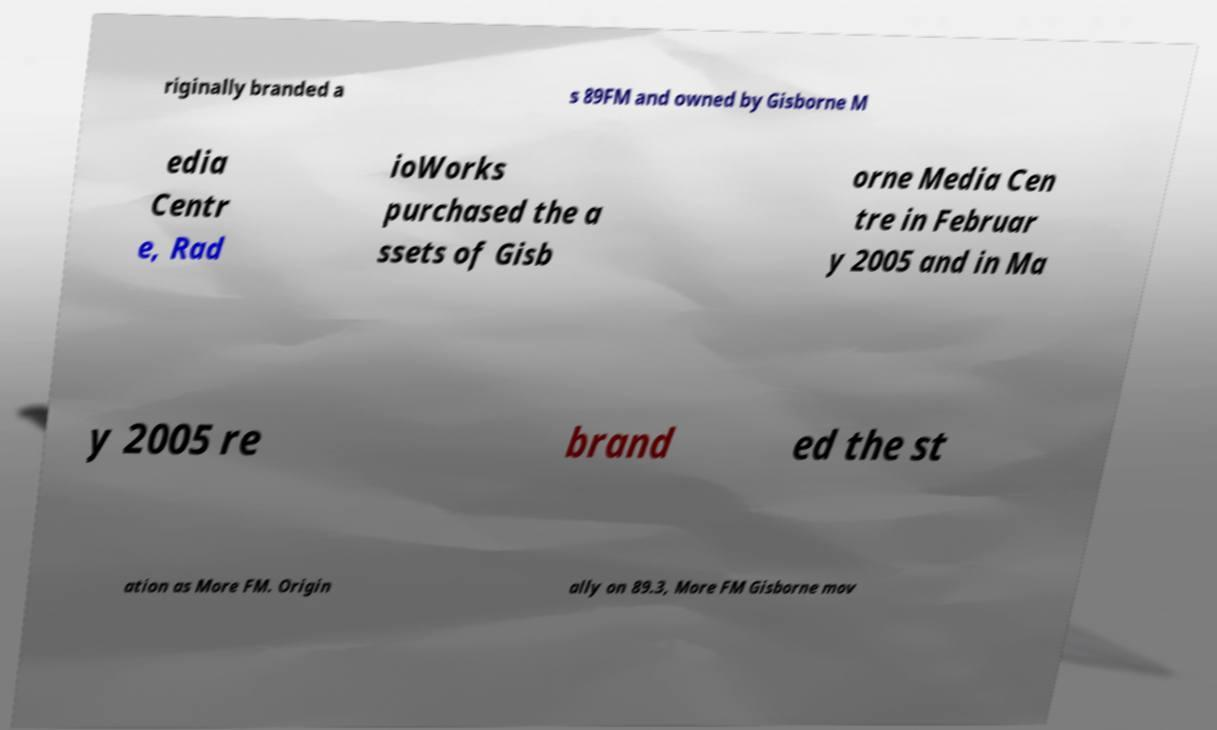For documentation purposes, I need the text within this image transcribed. Could you provide that? riginally branded a s 89FM and owned by Gisborne M edia Centr e, Rad ioWorks purchased the a ssets of Gisb orne Media Cen tre in Februar y 2005 and in Ma y 2005 re brand ed the st ation as More FM. Origin ally on 89.3, More FM Gisborne mov 